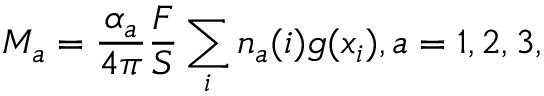<formula> <loc_0><loc_0><loc_500><loc_500>M _ { a } = \frac { \alpha _ { a } } { 4 \pi } \frac { F } { S } \sum _ { i } n _ { a } ( i ) g ( x _ { i } ) , a = 1 , 2 , 3 ,</formula> 